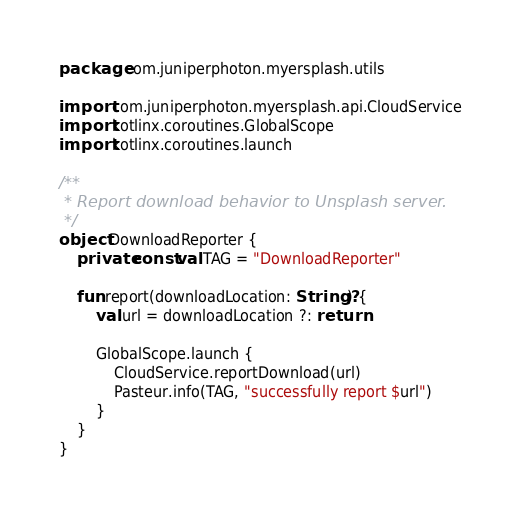<code> <loc_0><loc_0><loc_500><loc_500><_Kotlin_>package com.juniperphoton.myersplash.utils

import com.juniperphoton.myersplash.api.CloudService
import kotlinx.coroutines.GlobalScope
import kotlinx.coroutines.launch

/**
 * Report download behavior to Unsplash server.
 */
object DownloadReporter {
    private const val TAG = "DownloadReporter"

    fun report(downloadLocation: String?) {
        val url = downloadLocation ?: return

        GlobalScope.launch {
            CloudService.reportDownload(url)
            Pasteur.info(TAG, "successfully report $url")
        }
    }
}</code> 